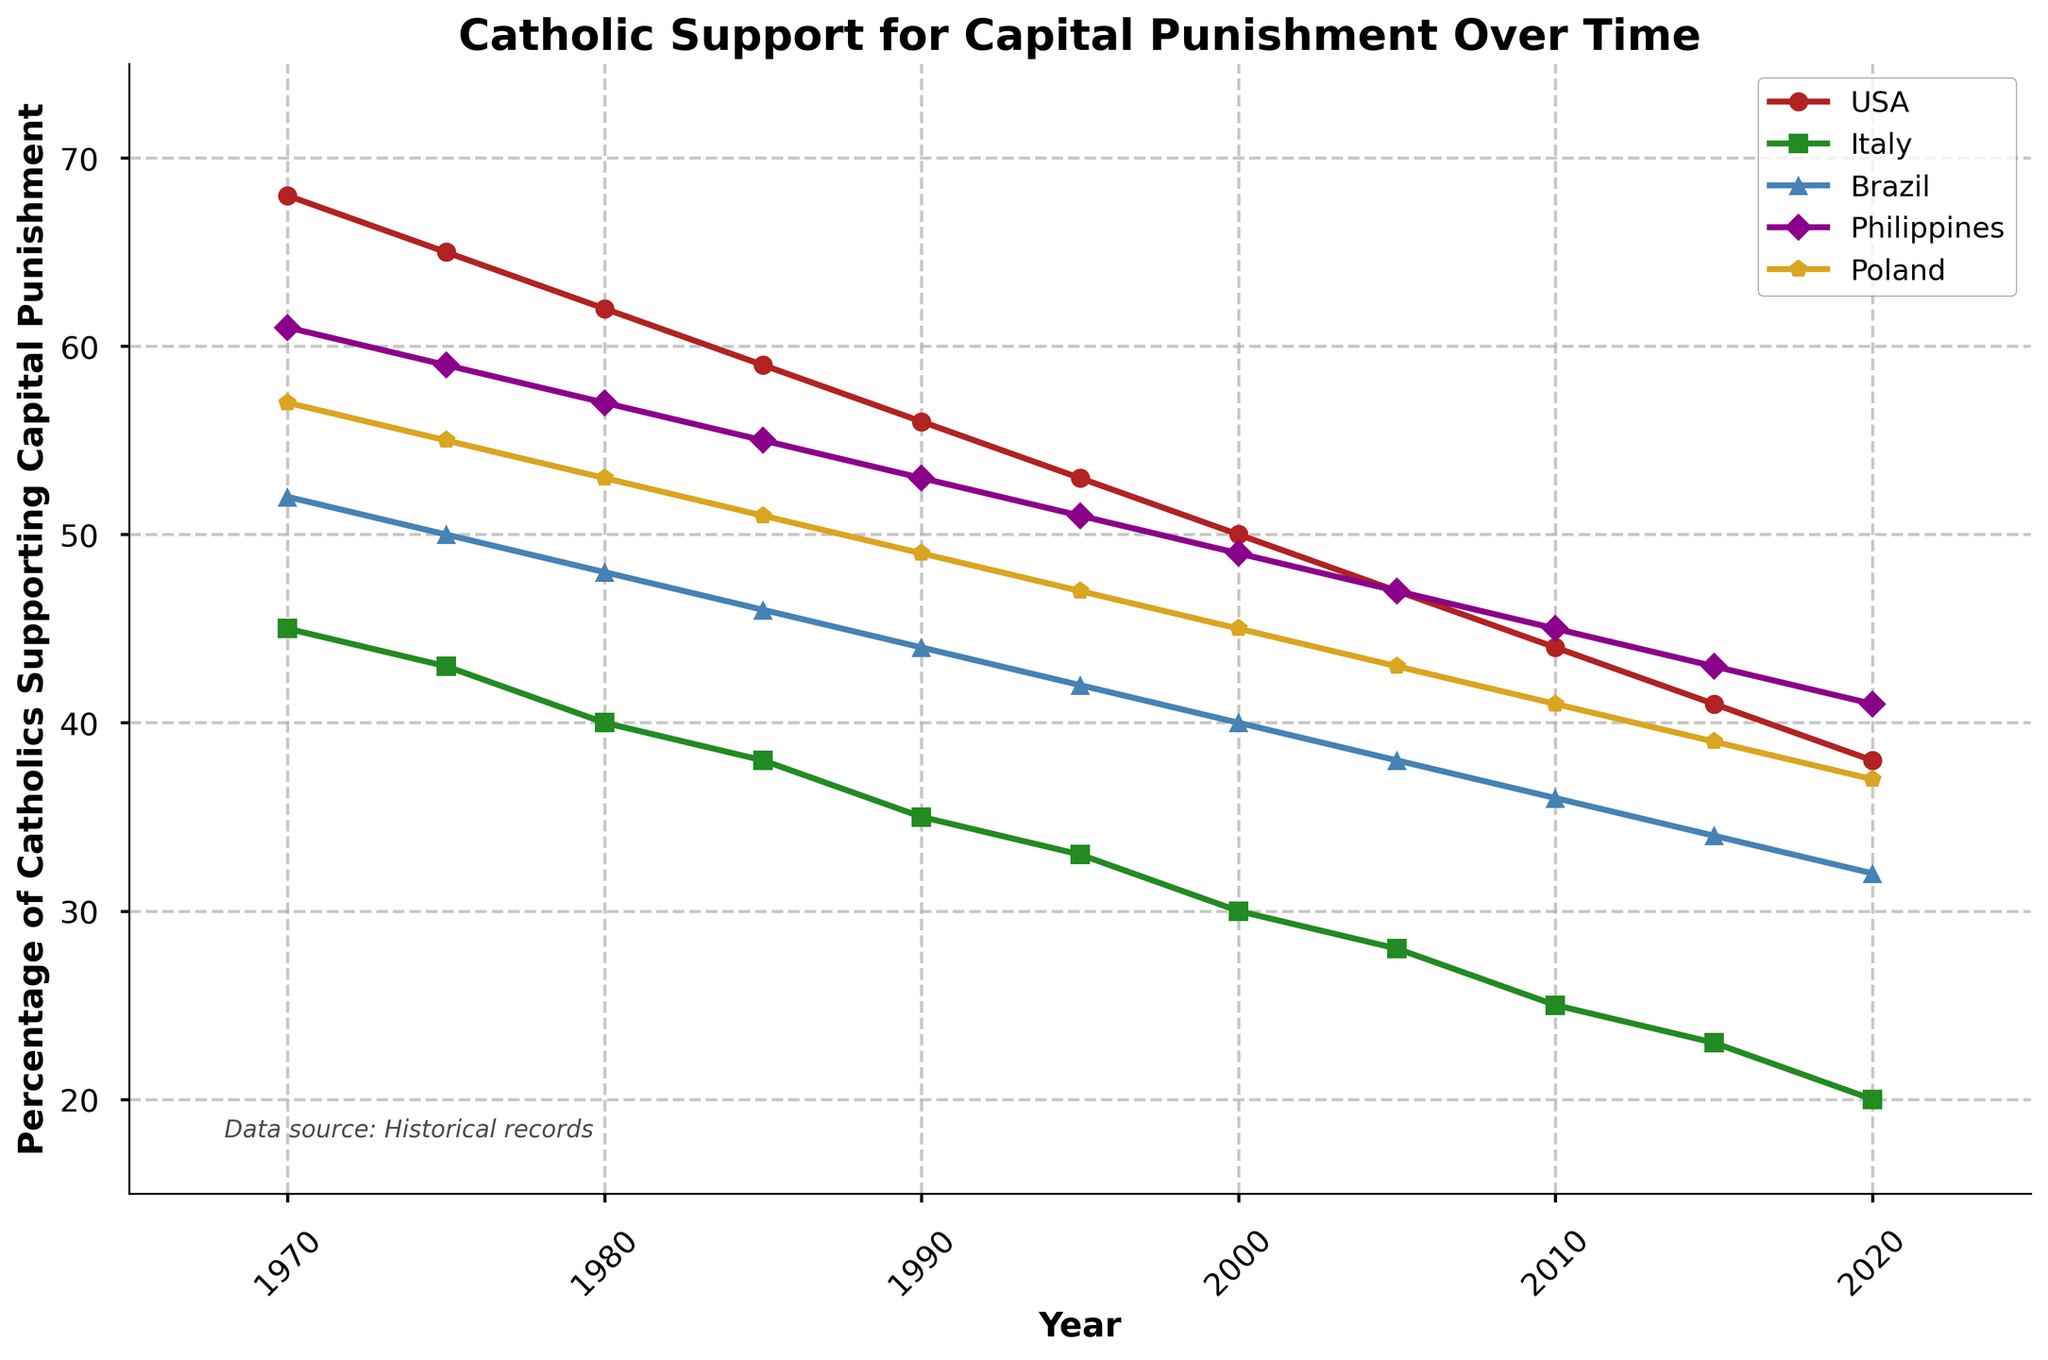How did the percentage of Catholics supporting capital punishment in the USA change from 1970 to 2020? The chart indicates the percentage of USA Catholics supporting capital punishment in 1970 was 68%. By 2020, this percentage had decreased to 38%. The difference is 68% - 38% = 30%.
Answer: Decreased by 30% Which country had the lowest percentage of Catholics supporting capital punishment in 2020? The chart shows the percentage of Catholics supporting capital punishment in various countries in 2020. Italy had the lowest percentage, at 20%.
Answer: Italy Which country's support for capital punishment showed the steepest decline over the decades? By observing the slopes of the lines, Italy's line descends most rapidly from 45% in 1970 to 20% in 2020, representing a decline of 25%.
Answer: Italy What is the average percentage of Catholics supporting capital punishment in Brazil in the years 1970, 1995, and 2020? The percentages for Brazil in the specified years are 52% (1970), 42% (1995), and 32% (2020). The average is calculated as (52 + 42 + 32) / 3 = 42%.
Answer: 42% Between which years did Poland see the greatest change in the percentage of support for capital punishment? The chart shows the percentages for Poland declining from 57% in 1970 to 37% in 2020. The largest drop occurs between 1970 and 1975, where it decreases from 57% to 55%, a 2% drop. However, the period with the greatest change isn't apparent without detailed steps through the chart. Reviewing each pair of years shows a gradual steady decline without sudden large drops. Thus, from 1970 to 2020 the drop is from 57% to 37% is 20%.
Answer: 1970-2020 What was the difference in the percentage of Catholics supporting capital punishment between Brazil and the Philippines in 2000? In 2000, the chart shows Brazil at 40% and the Philippines at 49%. The difference is 49% - 40% = 9%.
Answer: 9% How does the support for capital punishment in the Philippines in 2015 compare to that in Poland in 1980? Checking the chart, the Philippines' support is at 43% in 2015, while Poland's support is at 53% in 1980. Comparing them, the Philippines is 10% lower than Poland in the respective years.
Answer: Philippines is 10% lower Was there any year where the USA and Poland had the same percentage of Catholics supporting capital punishment? Observing the chart, there is no year where the percentages for the USA and Poland are equal. The lines for these two countries never intersect.
Answer: No What was the overall trend in Catholic support for capital punishment across all five countries between 1970 and 2020? The chart shows a general downward trend in support for capital punishment in all listed countries over the specified period.
Answer: Downward trend 